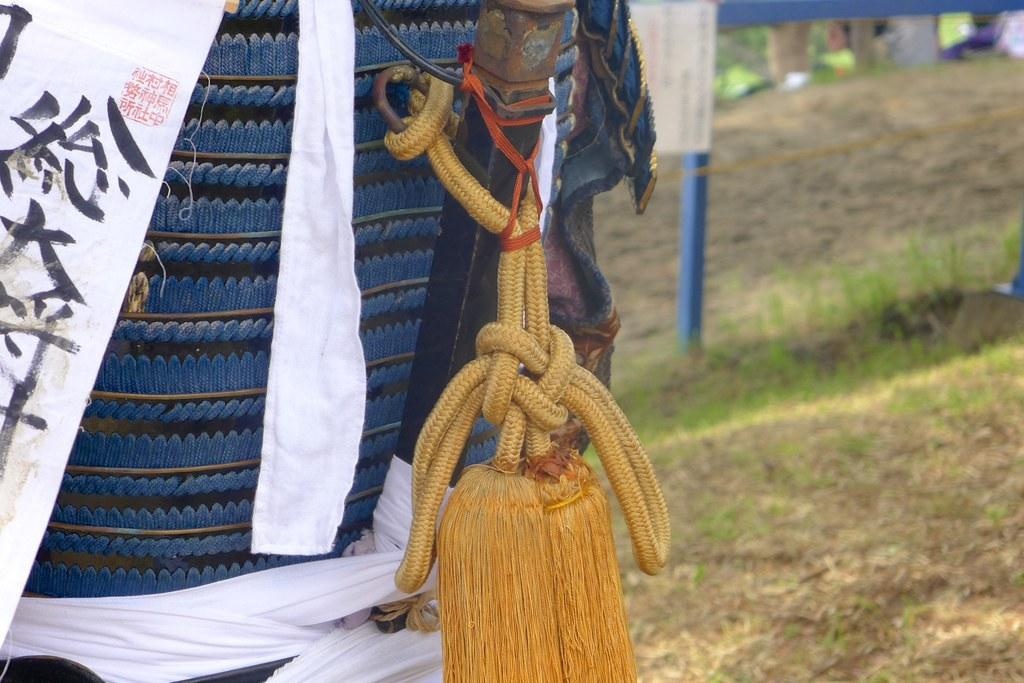What is the white object with writing on it in the image? It is not clear from the facts what the white object with writing is, but it is present in the image. How is the object tied to something else in the image? The facts do not specify how the object is tied to something else, but it is connected to another object in the image. What can be seen in the background of the image? In the background of the image, there is grass and a pole visible. What is the topic of the discussion taking place in the image? There is no discussion taking place in the image, as the facts do not mention any people or conversation. How does the fan contribute to the increase in temperature in the image? There is no fan present in the image, so it cannot contribute to any temperature changes. 